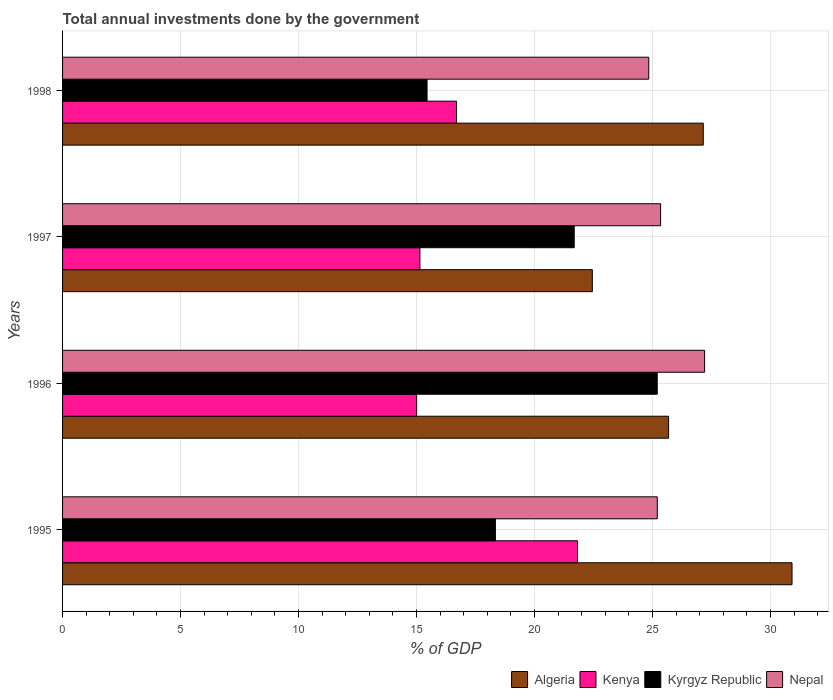How many different coloured bars are there?
Ensure brevity in your answer.  4. How many groups of bars are there?
Provide a short and direct response. 4. Are the number of bars on each tick of the Y-axis equal?
Provide a succinct answer. Yes. How many bars are there on the 3rd tick from the top?
Provide a short and direct response. 4. How many bars are there on the 1st tick from the bottom?
Keep it short and to the point. 4. What is the total annual investments done by the government in Kenya in 1995?
Keep it short and to the point. 21.82. Across all years, what is the maximum total annual investments done by the government in Kyrgyz Republic?
Ensure brevity in your answer.  25.2. Across all years, what is the minimum total annual investments done by the government in Nepal?
Offer a terse response. 24.84. In which year was the total annual investments done by the government in Kyrgyz Republic minimum?
Your answer should be compact. 1998. What is the total total annual investments done by the government in Nepal in the graph?
Keep it short and to the point. 102.58. What is the difference between the total annual investments done by the government in Kenya in 1995 and that in 1996?
Your answer should be compact. 6.82. What is the difference between the total annual investments done by the government in Algeria in 1998 and the total annual investments done by the government in Kenya in 1995?
Make the answer very short. 5.33. What is the average total annual investments done by the government in Kenya per year?
Give a very brief answer. 17.16. In the year 1996, what is the difference between the total annual investments done by the government in Algeria and total annual investments done by the government in Kyrgyz Republic?
Offer a terse response. 0.48. What is the ratio of the total annual investments done by the government in Nepal in 1996 to that in 1997?
Provide a short and direct response. 1.07. What is the difference between the highest and the second highest total annual investments done by the government in Kenya?
Make the answer very short. 5.13. What is the difference between the highest and the lowest total annual investments done by the government in Nepal?
Give a very brief answer. 2.37. Is it the case that in every year, the sum of the total annual investments done by the government in Algeria and total annual investments done by the government in Kenya is greater than the sum of total annual investments done by the government in Nepal and total annual investments done by the government in Kyrgyz Republic?
Give a very brief answer. Yes. What does the 4th bar from the top in 1996 represents?
Your answer should be compact. Algeria. What does the 3rd bar from the bottom in 1998 represents?
Ensure brevity in your answer.  Kyrgyz Republic. How many bars are there?
Provide a short and direct response. 16. Are all the bars in the graph horizontal?
Your response must be concise. Yes. How many years are there in the graph?
Offer a terse response. 4. What is the difference between two consecutive major ticks on the X-axis?
Offer a terse response. 5. Are the values on the major ticks of X-axis written in scientific E-notation?
Provide a short and direct response. No. Does the graph contain any zero values?
Ensure brevity in your answer.  No. Does the graph contain grids?
Provide a succinct answer. Yes. How many legend labels are there?
Your response must be concise. 4. What is the title of the graph?
Offer a very short reply. Total annual investments done by the government. Does "Mali" appear as one of the legend labels in the graph?
Ensure brevity in your answer.  No. What is the label or title of the X-axis?
Your answer should be compact. % of GDP. What is the label or title of the Y-axis?
Offer a very short reply. Years. What is the % of GDP in Algeria in 1995?
Give a very brief answer. 30.91. What is the % of GDP of Kenya in 1995?
Provide a succinct answer. 21.82. What is the % of GDP in Kyrgyz Republic in 1995?
Give a very brief answer. 18.34. What is the % of GDP in Nepal in 1995?
Keep it short and to the point. 25.2. What is the % of GDP in Algeria in 1996?
Provide a succinct answer. 25.68. What is the % of GDP of Kenya in 1996?
Your answer should be very brief. 15. What is the % of GDP in Kyrgyz Republic in 1996?
Your response must be concise. 25.2. What is the % of GDP in Nepal in 1996?
Offer a terse response. 27.21. What is the % of GDP in Algeria in 1997?
Offer a terse response. 22.45. What is the % of GDP in Kenya in 1997?
Offer a very short reply. 15.14. What is the % of GDP of Kyrgyz Republic in 1997?
Your answer should be very brief. 21.68. What is the % of GDP in Nepal in 1997?
Ensure brevity in your answer.  25.34. What is the % of GDP of Algeria in 1998?
Your response must be concise. 27.15. What is the % of GDP of Kenya in 1998?
Provide a succinct answer. 16.69. What is the % of GDP in Kyrgyz Republic in 1998?
Offer a terse response. 15.44. What is the % of GDP of Nepal in 1998?
Offer a terse response. 24.84. Across all years, what is the maximum % of GDP in Algeria?
Keep it short and to the point. 30.91. Across all years, what is the maximum % of GDP of Kenya?
Your answer should be compact. 21.82. Across all years, what is the maximum % of GDP of Kyrgyz Republic?
Give a very brief answer. 25.2. Across all years, what is the maximum % of GDP in Nepal?
Offer a very short reply. 27.21. Across all years, what is the minimum % of GDP of Algeria?
Ensure brevity in your answer.  22.45. Across all years, what is the minimum % of GDP in Kenya?
Give a very brief answer. 15. Across all years, what is the minimum % of GDP of Kyrgyz Republic?
Your response must be concise. 15.44. Across all years, what is the minimum % of GDP in Nepal?
Keep it short and to the point. 24.84. What is the total % of GDP of Algeria in the graph?
Offer a terse response. 106.18. What is the total % of GDP in Kenya in the graph?
Provide a succinct answer. 68.66. What is the total % of GDP in Kyrgyz Republic in the graph?
Your response must be concise. 80.66. What is the total % of GDP in Nepal in the graph?
Keep it short and to the point. 102.58. What is the difference between the % of GDP in Algeria in 1995 and that in 1996?
Ensure brevity in your answer.  5.23. What is the difference between the % of GDP of Kenya in 1995 and that in 1996?
Give a very brief answer. 6.82. What is the difference between the % of GDP of Kyrgyz Republic in 1995 and that in 1996?
Your answer should be compact. -6.86. What is the difference between the % of GDP of Nepal in 1995 and that in 1996?
Provide a succinct answer. -2.01. What is the difference between the % of GDP of Algeria in 1995 and that in 1997?
Your answer should be compact. 8.46. What is the difference between the % of GDP in Kenya in 1995 and that in 1997?
Your response must be concise. 6.68. What is the difference between the % of GDP of Kyrgyz Republic in 1995 and that in 1997?
Provide a succinct answer. -3.34. What is the difference between the % of GDP of Nepal in 1995 and that in 1997?
Give a very brief answer. -0.14. What is the difference between the % of GDP in Algeria in 1995 and that in 1998?
Ensure brevity in your answer.  3.76. What is the difference between the % of GDP of Kenya in 1995 and that in 1998?
Give a very brief answer. 5.13. What is the difference between the % of GDP in Kyrgyz Republic in 1995 and that in 1998?
Ensure brevity in your answer.  2.9. What is the difference between the % of GDP of Nepal in 1995 and that in 1998?
Offer a terse response. 0.36. What is the difference between the % of GDP of Algeria in 1996 and that in 1997?
Offer a very short reply. 3.23. What is the difference between the % of GDP in Kenya in 1996 and that in 1997?
Make the answer very short. -0.14. What is the difference between the % of GDP of Kyrgyz Republic in 1996 and that in 1997?
Offer a very short reply. 3.52. What is the difference between the % of GDP of Nepal in 1996 and that in 1997?
Provide a short and direct response. 1.86. What is the difference between the % of GDP in Algeria in 1996 and that in 1998?
Keep it short and to the point. -1.47. What is the difference between the % of GDP in Kenya in 1996 and that in 1998?
Provide a short and direct response. -1.69. What is the difference between the % of GDP of Kyrgyz Republic in 1996 and that in 1998?
Your answer should be compact. 9.75. What is the difference between the % of GDP of Nepal in 1996 and that in 1998?
Offer a terse response. 2.37. What is the difference between the % of GDP of Algeria in 1997 and that in 1998?
Give a very brief answer. -4.7. What is the difference between the % of GDP of Kenya in 1997 and that in 1998?
Provide a succinct answer. -1.55. What is the difference between the % of GDP in Kyrgyz Republic in 1997 and that in 1998?
Your response must be concise. 6.24. What is the difference between the % of GDP of Nepal in 1997 and that in 1998?
Provide a short and direct response. 0.5. What is the difference between the % of GDP in Algeria in 1995 and the % of GDP in Kenya in 1996?
Give a very brief answer. 15.9. What is the difference between the % of GDP in Algeria in 1995 and the % of GDP in Kyrgyz Republic in 1996?
Keep it short and to the point. 5.71. What is the difference between the % of GDP in Algeria in 1995 and the % of GDP in Nepal in 1996?
Keep it short and to the point. 3.7. What is the difference between the % of GDP in Kenya in 1995 and the % of GDP in Kyrgyz Republic in 1996?
Provide a succinct answer. -3.38. What is the difference between the % of GDP in Kenya in 1995 and the % of GDP in Nepal in 1996?
Keep it short and to the point. -5.39. What is the difference between the % of GDP in Kyrgyz Republic in 1995 and the % of GDP in Nepal in 1996?
Your answer should be very brief. -8.87. What is the difference between the % of GDP of Algeria in 1995 and the % of GDP of Kenya in 1997?
Your answer should be compact. 15.77. What is the difference between the % of GDP in Algeria in 1995 and the % of GDP in Kyrgyz Republic in 1997?
Provide a succinct answer. 9.23. What is the difference between the % of GDP in Algeria in 1995 and the % of GDP in Nepal in 1997?
Give a very brief answer. 5.57. What is the difference between the % of GDP in Kenya in 1995 and the % of GDP in Kyrgyz Republic in 1997?
Offer a very short reply. 0.14. What is the difference between the % of GDP in Kenya in 1995 and the % of GDP in Nepal in 1997?
Offer a terse response. -3.52. What is the difference between the % of GDP in Kyrgyz Republic in 1995 and the % of GDP in Nepal in 1997?
Offer a terse response. -7. What is the difference between the % of GDP in Algeria in 1995 and the % of GDP in Kenya in 1998?
Offer a very short reply. 14.22. What is the difference between the % of GDP in Algeria in 1995 and the % of GDP in Kyrgyz Republic in 1998?
Make the answer very short. 15.46. What is the difference between the % of GDP of Algeria in 1995 and the % of GDP of Nepal in 1998?
Keep it short and to the point. 6.07. What is the difference between the % of GDP of Kenya in 1995 and the % of GDP of Kyrgyz Republic in 1998?
Give a very brief answer. 6.38. What is the difference between the % of GDP of Kenya in 1995 and the % of GDP of Nepal in 1998?
Provide a short and direct response. -3.02. What is the difference between the % of GDP in Kyrgyz Republic in 1995 and the % of GDP in Nepal in 1998?
Provide a short and direct response. -6.5. What is the difference between the % of GDP in Algeria in 1996 and the % of GDP in Kenya in 1997?
Give a very brief answer. 10.54. What is the difference between the % of GDP in Algeria in 1996 and the % of GDP in Kyrgyz Republic in 1997?
Make the answer very short. 4. What is the difference between the % of GDP of Algeria in 1996 and the % of GDP of Nepal in 1997?
Your response must be concise. 0.34. What is the difference between the % of GDP of Kenya in 1996 and the % of GDP of Kyrgyz Republic in 1997?
Your answer should be compact. -6.68. What is the difference between the % of GDP of Kenya in 1996 and the % of GDP of Nepal in 1997?
Ensure brevity in your answer.  -10.34. What is the difference between the % of GDP of Kyrgyz Republic in 1996 and the % of GDP of Nepal in 1997?
Make the answer very short. -0.14. What is the difference between the % of GDP in Algeria in 1996 and the % of GDP in Kenya in 1998?
Give a very brief answer. 8.99. What is the difference between the % of GDP in Algeria in 1996 and the % of GDP in Kyrgyz Republic in 1998?
Give a very brief answer. 10.23. What is the difference between the % of GDP in Algeria in 1996 and the % of GDP in Nepal in 1998?
Give a very brief answer. 0.84. What is the difference between the % of GDP in Kenya in 1996 and the % of GDP in Kyrgyz Republic in 1998?
Keep it short and to the point. -0.44. What is the difference between the % of GDP in Kenya in 1996 and the % of GDP in Nepal in 1998?
Give a very brief answer. -9.84. What is the difference between the % of GDP in Kyrgyz Republic in 1996 and the % of GDP in Nepal in 1998?
Your answer should be very brief. 0.36. What is the difference between the % of GDP in Algeria in 1997 and the % of GDP in Kenya in 1998?
Make the answer very short. 5.75. What is the difference between the % of GDP in Algeria in 1997 and the % of GDP in Kyrgyz Republic in 1998?
Your response must be concise. 7. What is the difference between the % of GDP in Algeria in 1997 and the % of GDP in Nepal in 1998?
Your answer should be very brief. -2.39. What is the difference between the % of GDP in Kenya in 1997 and the % of GDP in Kyrgyz Republic in 1998?
Make the answer very short. -0.3. What is the difference between the % of GDP in Kenya in 1997 and the % of GDP in Nepal in 1998?
Give a very brief answer. -9.7. What is the difference between the % of GDP of Kyrgyz Republic in 1997 and the % of GDP of Nepal in 1998?
Ensure brevity in your answer.  -3.16. What is the average % of GDP in Algeria per year?
Your answer should be very brief. 26.55. What is the average % of GDP of Kenya per year?
Ensure brevity in your answer.  17.16. What is the average % of GDP in Kyrgyz Republic per year?
Make the answer very short. 20.17. What is the average % of GDP in Nepal per year?
Keep it short and to the point. 25.65. In the year 1995, what is the difference between the % of GDP of Algeria and % of GDP of Kenya?
Ensure brevity in your answer.  9.09. In the year 1995, what is the difference between the % of GDP of Algeria and % of GDP of Kyrgyz Republic?
Provide a short and direct response. 12.57. In the year 1995, what is the difference between the % of GDP of Algeria and % of GDP of Nepal?
Provide a short and direct response. 5.71. In the year 1995, what is the difference between the % of GDP of Kenya and % of GDP of Kyrgyz Republic?
Ensure brevity in your answer.  3.48. In the year 1995, what is the difference between the % of GDP in Kenya and % of GDP in Nepal?
Provide a short and direct response. -3.38. In the year 1995, what is the difference between the % of GDP of Kyrgyz Republic and % of GDP of Nepal?
Provide a short and direct response. -6.86. In the year 1996, what is the difference between the % of GDP of Algeria and % of GDP of Kenya?
Your answer should be compact. 10.67. In the year 1996, what is the difference between the % of GDP of Algeria and % of GDP of Kyrgyz Republic?
Ensure brevity in your answer.  0.48. In the year 1996, what is the difference between the % of GDP in Algeria and % of GDP in Nepal?
Ensure brevity in your answer.  -1.53. In the year 1996, what is the difference between the % of GDP in Kenya and % of GDP in Kyrgyz Republic?
Ensure brevity in your answer.  -10.19. In the year 1996, what is the difference between the % of GDP of Kenya and % of GDP of Nepal?
Make the answer very short. -12.2. In the year 1996, what is the difference between the % of GDP in Kyrgyz Republic and % of GDP in Nepal?
Make the answer very short. -2.01. In the year 1997, what is the difference between the % of GDP of Algeria and % of GDP of Kenya?
Ensure brevity in your answer.  7.31. In the year 1997, what is the difference between the % of GDP in Algeria and % of GDP in Kyrgyz Republic?
Keep it short and to the point. 0.77. In the year 1997, what is the difference between the % of GDP in Algeria and % of GDP in Nepal?
Make the answer very short. -2.89. In the year 1997, what is the difference between the % of GDP of Kenya and % of GDP of Kyrgyz Republic?
Ensure brevity in your answer.  -6.54. In the year 1997, what is the difference between the % of GDP of Kenya and % of GDP of Nepal?
Offer a terse response. -10.2. In the year 1997, what is the difference between the % of GDP of Kyrgyz Republic and % of GDP of Nepal?
Your answer should be compact. -3.66. In the year 1998, what is the difference between the % of GDP of Algeria and % of GDP of Kenya?
Provide a short and direct response. 10.46. In the year 1998, what is the difference between the % of GDP in Algeria and % of GDP in Kyrgyz Republic?
Keep it short and to the point. 11.7. In the year 1998, what is the difference between the % of GDP in Algeria and % of GDP in Nepal?
Offer a very short reply. 2.31. In the year 1998, what is the difference between the % of GDP in Kenya and % of GDP in Kyrgyz Republic?
Make the answer very short. 1.25. In the year 1998, what is the difference between the % of GDP of Kenya and % of GDP of Nepal?
Make the answer very short. -8.15. In the year 1998, what is the difference between the % of GDP of Kyrgyz Republic and % of GDP of Nepal?
Your answer should be compact. -9.4. What is the ratio of the % of GDP in Algeria in 1995 to that in 1996?
Keep it short and to the point. 1.2. What is the ratio of the % of GDP in Kenya in 1995 to that in 1996?
Provide a succinct answer. 1.45. What is the ratio of the % of GDP in Kyrgyz Republic in 1995 to that in 1996?
Your answer should be very brief. 0.73. What is the ratio of the % of GDP in Nepal in 1995 to that in 1996?
Make the answer very short. 0.93. What is the ratio of the % of GDP of Algeria in 1995 to that in 1997?
Give a very brief answer. 1.38. What is the ratio of the % of GDP of Kenya in 1995 to that in 1997?
Your response must be concise. 1.44. What is the ratio of the % of GDP of Kyrgyz Republic in 1995 to that in 1997?
Provide a succinct answer. 0.85. What is the ratio of the % of GDP of Algeria in 1995 to that in 1998?
Your response must be concise. 1.14. What is the ratio of the % of GDP of Kenya in 1995 to that in 1998?
Keep it short and to the point. 1.31. What is the ratio of the % of GDP in Kyrgyz Republic in 1995 to that in 1998?
Provide a succinct answer. 1.19. What is the ratio of the % of GDP in Nepal in 1995 to that in 1998?
Your answer should be very brief. 1.01. What is the ratio of the % of GDP of Algeria in 1996 to that in 1997?
Your response must be concise. 1.14. What is the ratio of the % of GDP of Kenya in 1996 to that in 1997?
Offer a very short reply. 0.99. What is the ratio of the % of GDP of Kyrgyz Republic in 1996 to that in 1997?
Make the answer very short. 1.16. What is the ratio of the % of GDP in Nepal in 1996 to that in 1997?
Your answer should be very brief. 1.07. What is the ratio of the % of GDP in Algeria in 1996 to that in 1998?
Provide a succinct answer. 0.95. What is the ratio of the % of GDP of Kenya in 1996 to that in 1998?
Your answer should be compact. 0.9. What is the ratio of the % of GDP in Kyrgyz Republic in 1996 to that in 1998?
Make the answer very short. 1.63. What is the ratio of the % of GDP in Nepal in 1996 to that in 1998?
Provide a short and direct response. 1.1. What is the ratio of the % of GDP in Algeria in 1997 to that in 1998?
Keep it short and to the point. 0.83. What is the ratio of the % of GDP in Kenya in 1997 to that in 1998?
Your answer should be compact. 0.91. What is the ratio of the % of GDP of Kyrgyz Republic in 1997 to that in 1998?
Keep it short and to the point. 1.4. What is the ratio of the % of GDP of Nepal in 1997 to that in 1998?
Offer a very short reply. 1.02. What is the difference between the highest and the second highest % of GDP of Algeria?
Your answer should be compact. 3.76. What is the difference between the highest and the second highest % of GDP of Kenya?
Keep it short and to the point. 5.13. What is the difference between the highest and the second highest % of GDP in Kyrgyz Republic?
Provide a short and direct response. 3.52. What is the difference between the highest and the second highest % of GDP of Nepal?
Your answer should be very brief. 1.86. What is the difference between the highest and the lowest % of GDP of Algeria?
Make the answer very short. 8.46. What is the difference between the highest and the lowest % of GDP of Kenya?
Keep it short and to the point. 6.82. What is the difference between the highest and the lowest % of GDP in Kyrgyz Republic?
Provide a succinct answer. 9.75. What is the difference between the highest and the lowest % of GDP in Nepal?
Offer a very short reply. 2.37. 